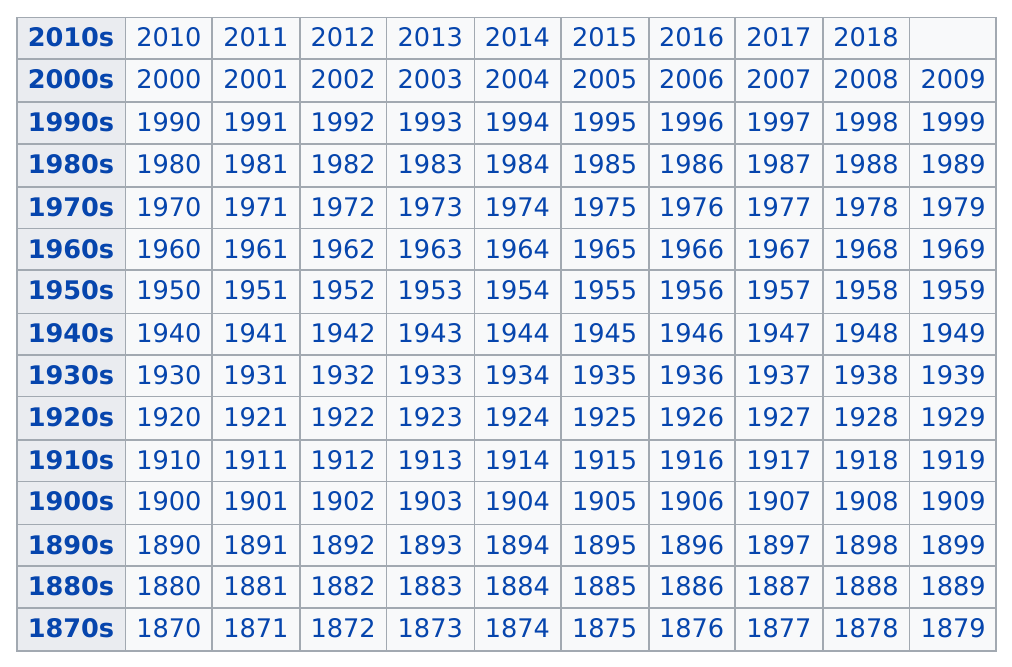Outline some significant characteristics in this image. The earliest year that a film was released is 1870. In the year 2019, there is no year after it on the table. Mathematically speaking, the difference between 2015 and 1912 is 103 years. The 2010s are the only decade to have fewer years than the others. It is true that all years are arranged in a consecutive order. 